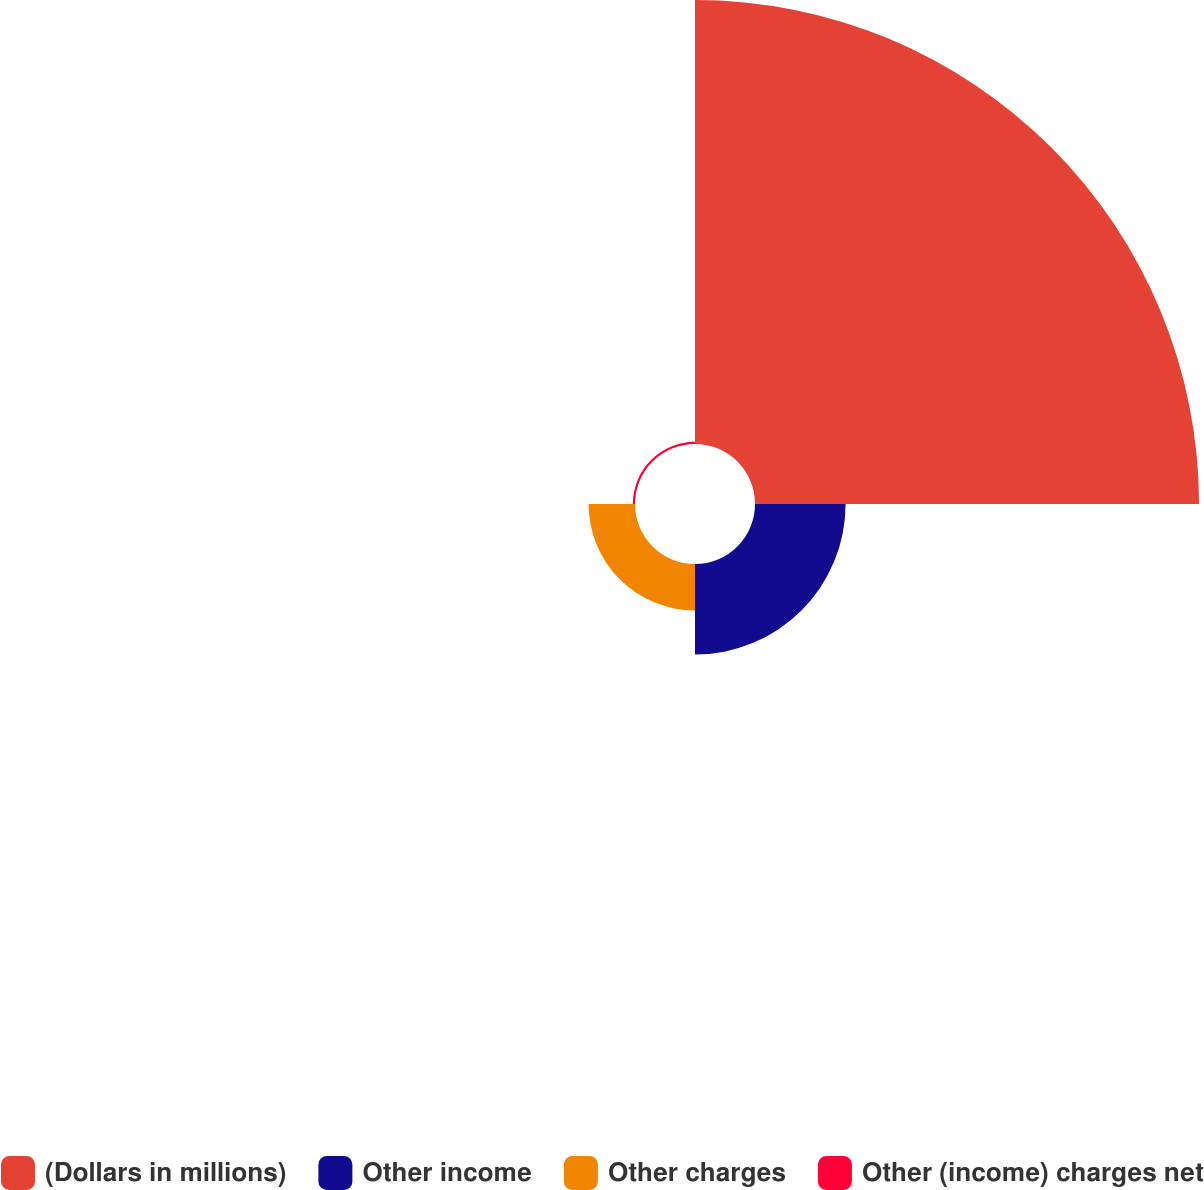Convert chart. <chart><loc_0><loc_0><loc_500><loc_500><pie_chart><fcel>(Dollars in millions)<fcel>Other income<fcel>Other charges<fcel>Other (income) charges net<nl><fcel>76.13%<fcel>15.53%<fcel>7.96%<fcel>0.38%<nl></chart> 